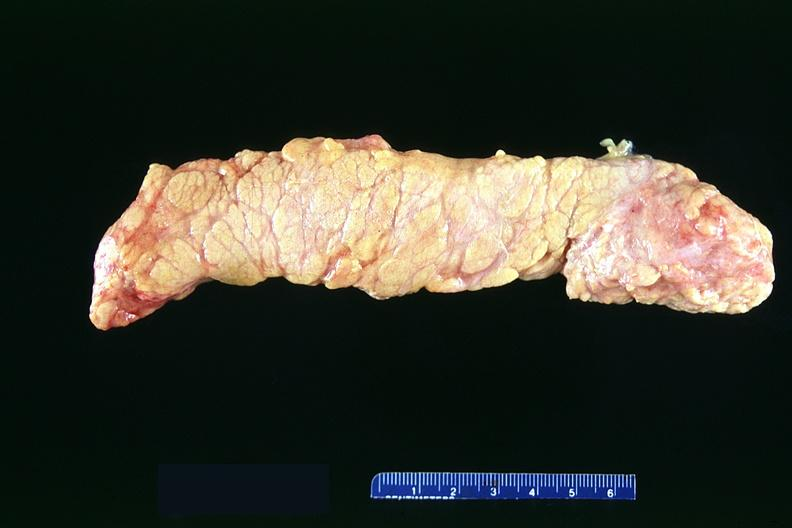does this image show normal pancreas?
Answer the question using a single word or phrase. Yes 